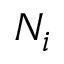<formula> <loc_0><loc_0><loc_500><loc_500>N _ { i }</formula> 